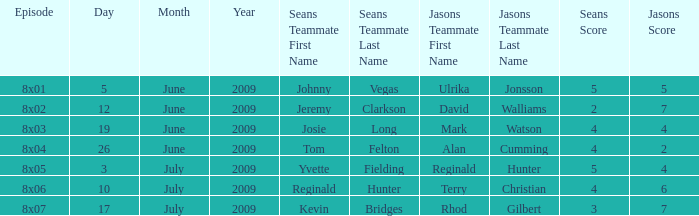In how many episodes did Sean's team include Jeremy Clarkson and James McQuillan? 1.0. 